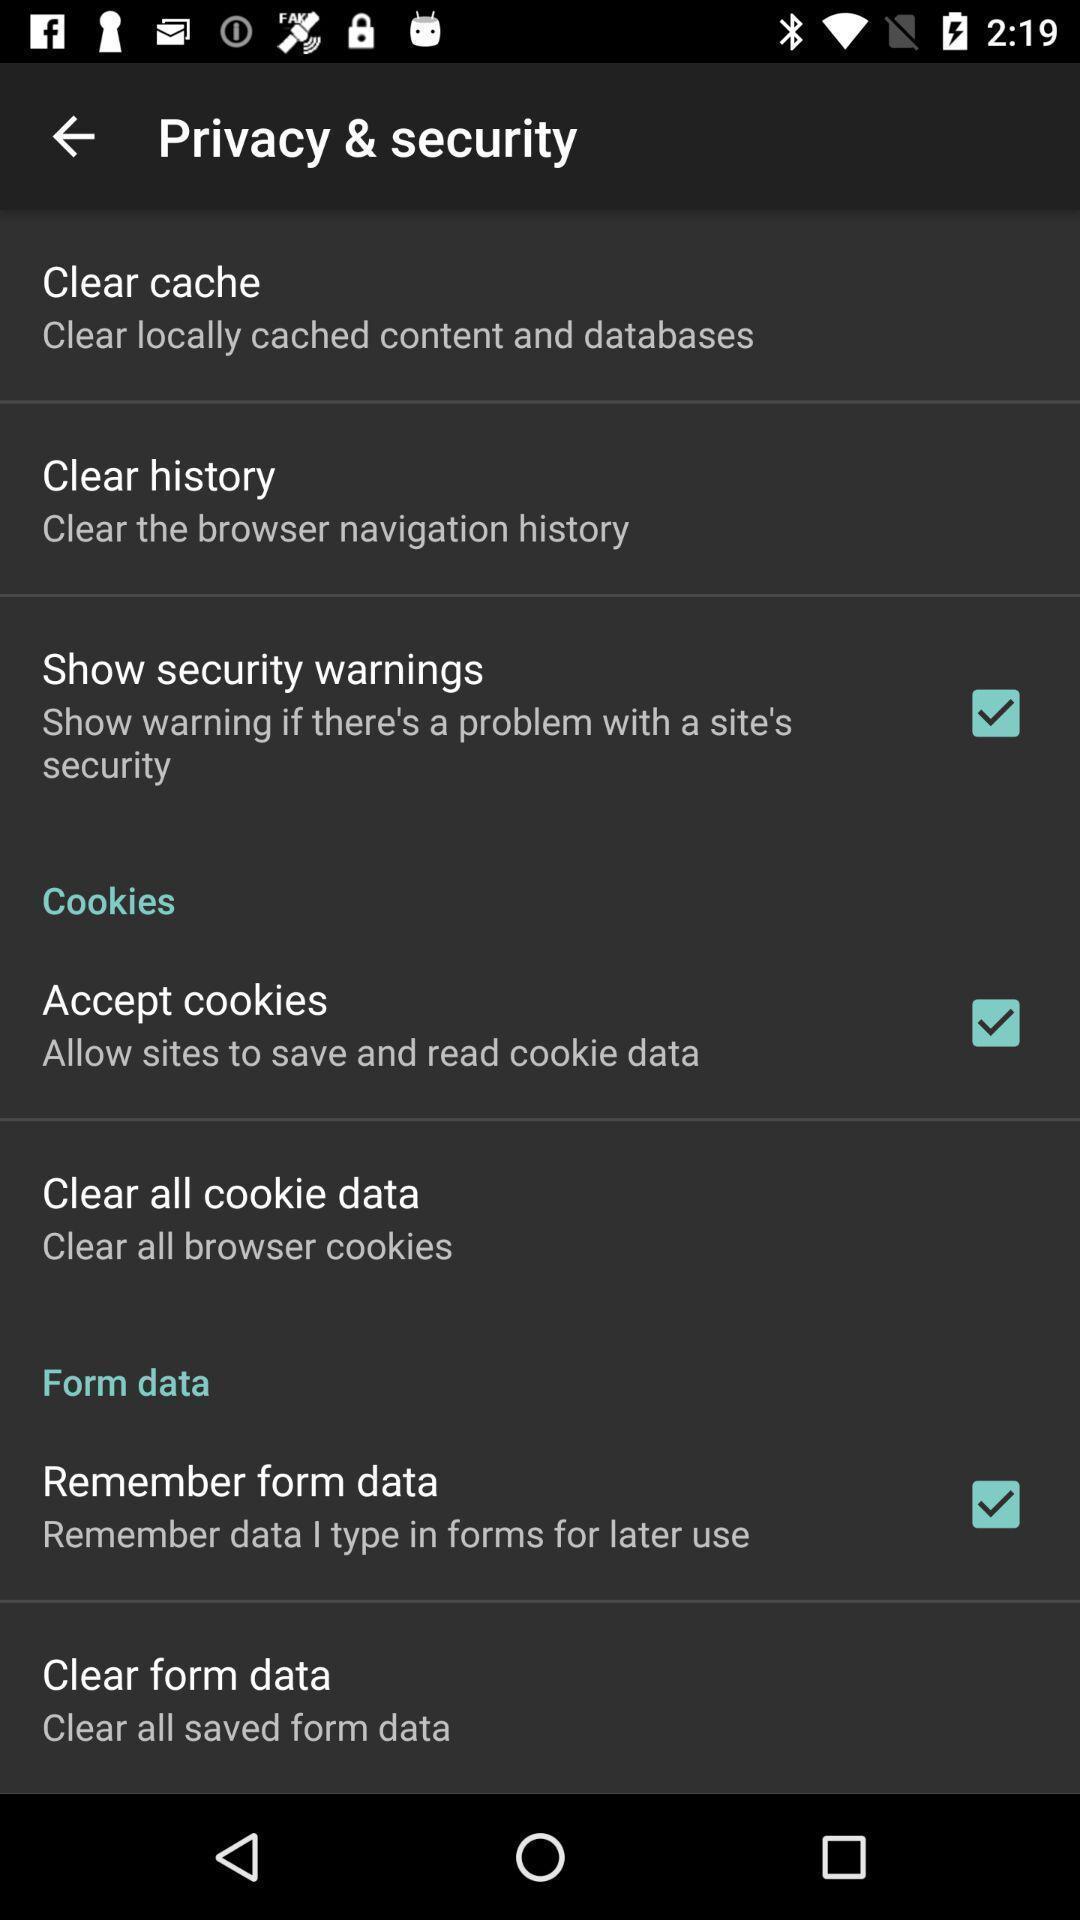Describe the content in this image. Page with multiple options for privacy settings. 